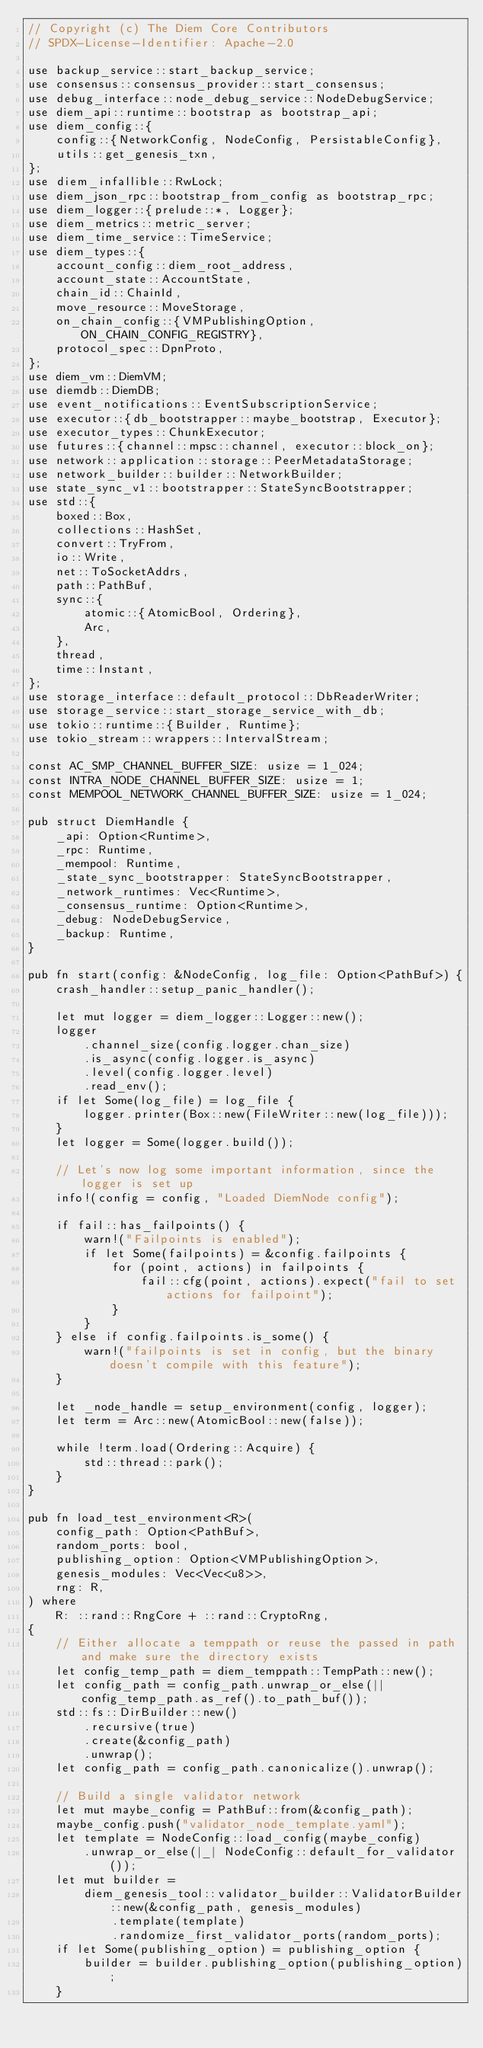Convert code to text. <code><loc_0><loc_0><loc_500><loc_500><_Rust_>// Copyright (c) The Diem Core Contributors
// SPDX-License-Identifier: Apache-2.0

use backup_service::start_backup_service;
use consensus::consensus_provider::start_consensus;
use debug_interface::node_debug_service::NodeDebugService;
use diem_api::runtime::bootstrap as bootstrap_api;
use diem_config::{
    config::{NetworkConfig, NodeConfig, PersistableConfig},
    utils::get_genesis_txn,
};
use diem_infallible::RwLock;
use diem_json_rpc::bootstrap_from_config as bootstrap_rpc;
use diem_logger::{prelude::*, Logger};
use diem_metrics::metric_server;
use diem_time_service::TimeService;
use diem_types::{
    account_config::diem_root_address,
    account_state::AccountState,
    chain_id::ChainId,
    move_resource::MoveStorage,
    on_chain_config::{VMPublishingOption, ON_CHAIN_CONFIG_REGISTRY},
    protocol_spec::DpnProto,
};
use diem_vm::DiemVM;
use diemdb::DiemDB;
use event_notifications::EventSubscriptionService;
use executor::{db_bootstrapper::maybe_bootstrap, Executor};
use executor_types::ChunkExecutor;
use futures::{channel::mpsc::channel, executor::block_on};
use network::application::storage::PeerMetadataStorage;
use network_builder::builder::NetworkBuilder;
use state_sync_v1::bootstrapper::StateSyncBootstrapper;
use std::{
    boxed::Box,
    collections::HashSet,
    convert::TryFrom,
    io::Write,
    net::ToSocketAddrs,
    path::PathBuf,
    sync::{
        atomic::{AtomicBool, Ordering},
        Arc,
    },
    thread,
    time::Instant,
};
use storage_interface::default_protocol::DbReaderWriter;
use storage_service::start_storage_service_with_db;
use tokio::runtime::{Builder, Runtime};
use tokio_stream::wrappers::IntervalStream;

const AC_SMP_CHANNEL_BUFFER_SIZE: usize = 1_024;
const INTRA_NODE_CHANNEL_BUFFER_SIZE: usize = 1;
const MEMPOOL_NETWORK_CHANNEL_BUFFER_SIZE: usize = 1_024;

pub struct DiemHandle {
    _api: Option<Runtime>,
    _rpc: Runtime,
    _mempool: Runtime,
    _state_sync_bootstrapper: StateSyncBootstrapper,
    _network_runtimes: Vec<Runtime>,
    _consensus_runtime: Option<Runtime>,
    _debug: NodeDebugService,
    _backup: Runtime,
}

pub fn start(config: &NodeConfig, log_file: Option<PathBuf>) {
    crash_handler::setup_panic_handler();

    let mut logger = diem_logger::Logger::new();
    logger
        .channel_size(config.logger.chan_size)
        .is_async(config.logger.is_async)
        .level(config.logger.level)
        .read_env();
    if let Some(log_file) = log_file {
        logger.printer(Box::new(FileWriter::new(log_file)));
    }
    let logger = Some(logger.build());

    // Let's now log some important information, since the logger is set up
    info!(config = config, "Loaded DiemNode config");

    if fail::has_failpoints() {
        warn!("Failpoints is enabled");
        if let Some(failpoints) = &config.failpoints {
            for (point, actions) in failpoints {
                fail::cfg(point, actions).expect("fail to set actions for failpoint");
            }
        }
    } else if config.failpoints.is_some() {
        warn!("failpoints is set in config, but the binary doesn't compile with this feature");
    }

    let _node_handle = setup_environment(config, logger);
    let term = Arc::new(AtomicBool::new(false));

    while !term.load(Ordering::Acquire) {
        std::thread::park();
    }
}

pub fn load_test_environment<R>(
    config_path: Option<PathBuf>,
    random_ports: bool,
    publishing_option: Option<VMPublishingOption>,
    genesis_modules: Vec<Vec<u8>>,
    rng: R,
) where
    R: ::rand::RngCore + ::rand::CryptoRng,
{
    // Either allocate a temppath or reuse the passed in path and make sure the directory exists
    let config_temp_path = diem_temppath::TempPath::new();
    let config_path = config_path.unwrap_or_else(|| config_temp_path.as_ref().to_path_buf());
    std::fs::DirBuilder::new()
        .recursive(true)
        .create(&config_path)
        .unwrap();
    let config_path = config_path.canonicalize().unwrap();

    // Build a single validator network
    let mut maybe_config = PathBuf::from(&config_path);
    maybe_config.push("validator_node_template.yaml");
    let template = NodeConfig::load_config(maybe_config)
        .unwrap_or_else(|_| NodeConfig::default_for_validator());
    let mut builder =
        diem_genesis_tool::validator_builder::ValidatorBuilder::new(&config_path, genesis_modules)
            .template(template)
            .randomize_first_validator_ports(random_ports);
    if let Some(publishing_option) = publishing_option {
        builder = builder.publishing_option(publishing_option);
    }</code> 